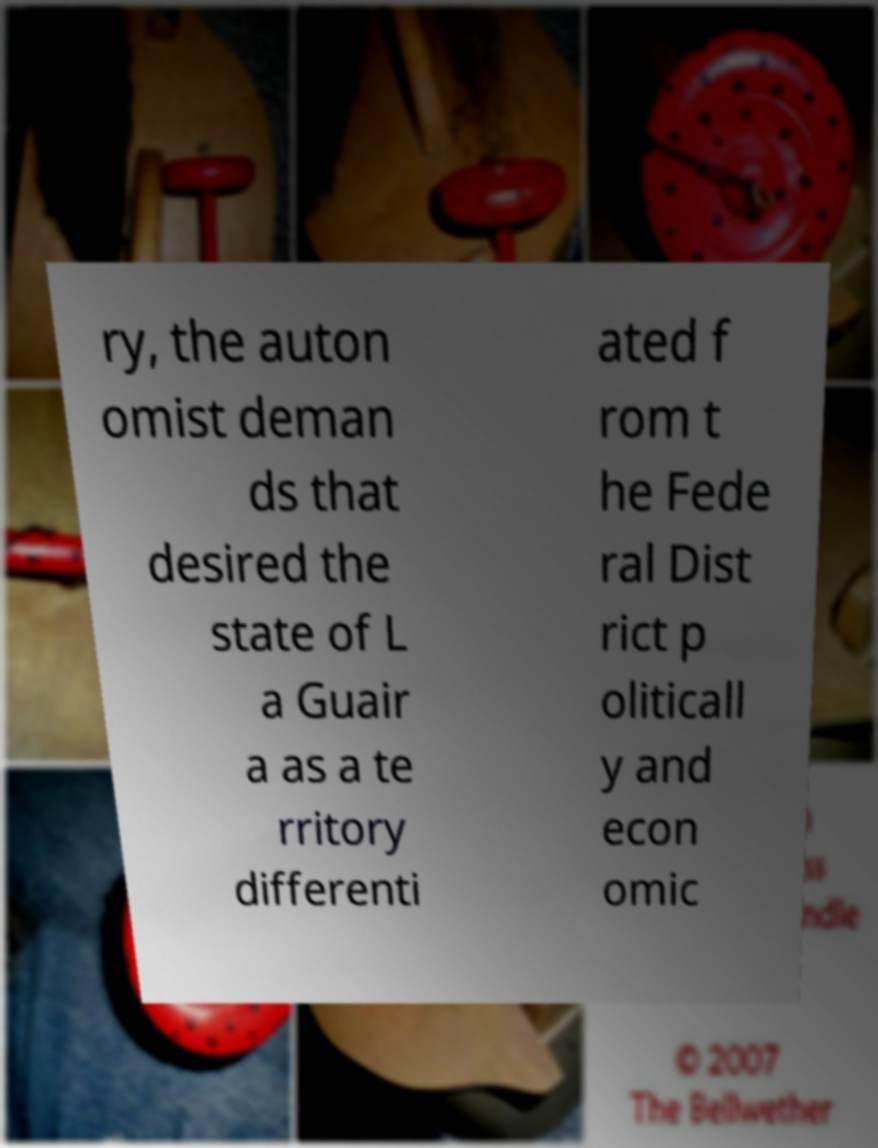There's text embedded in this image that I need extracted. Can you transcribe it verbatim? ry, the auton omist deman ds that desired the state of L a Guair a as a te rritory differenti ated f rom t he Fede ral Dist rict p oliticall y and econ omic 